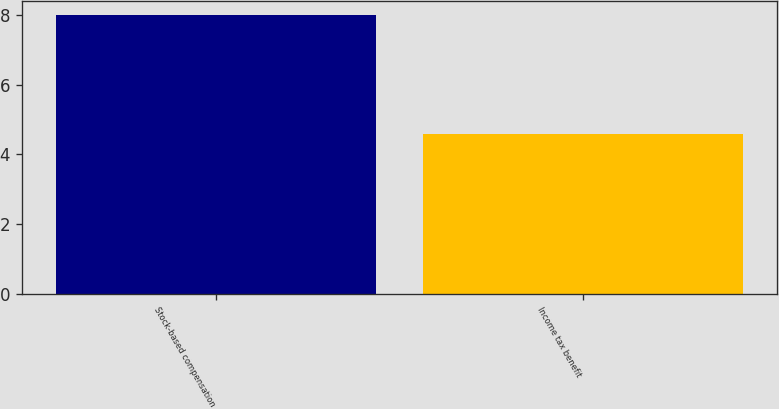Convert chart to OTSL. <chart><loc_0><loc_0><loc_500><loc_500><bar_chart><fcel>Stock-based compensation<fcel>Income tax benefit<nl><fcel>8<fcel>4.6<nl></chart> 